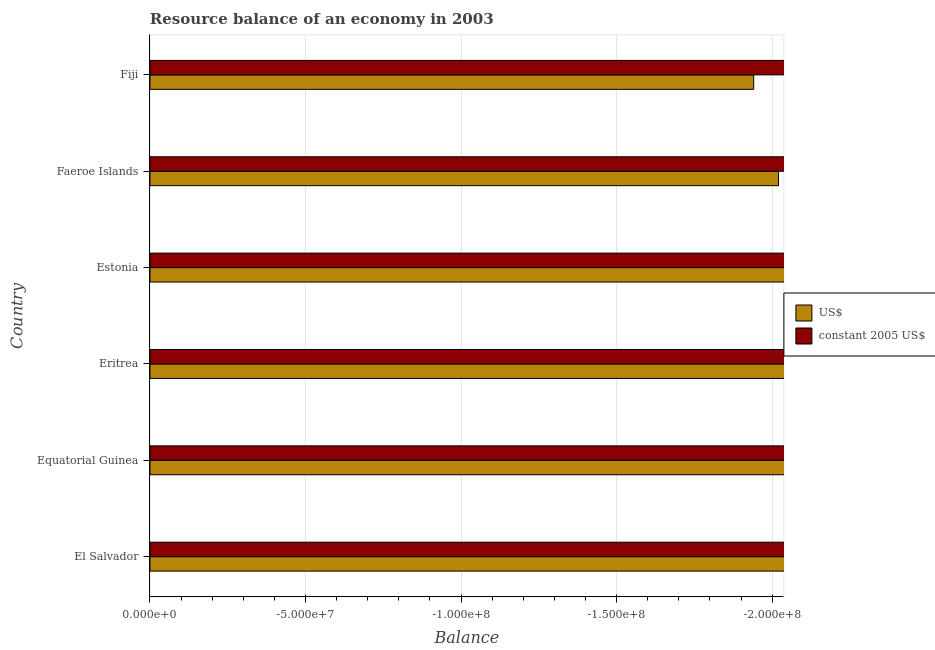Are the number of bars per tick equal to the number of legend labels?
Provide a short and direct response. No. Are the number of bars on each tick of the Y-axis equal?
Your answer should be very brief. Yes. How many bars are there on the 3rd tick from the top?
Keep it short and to the point. 0. What is the label of the 5th group of bars from the top?
Ensure brevity in your answer.  Equatorial Guinea. What is the resource balance in constant us$ in Estonia?
Keep it short and to the point. 0. What is the total resource balance in us$ in the graph?
Make the answer very short. 0. How many bars are there?
Keep it short and to the point. 0. Are all the bars in the graph horizontal?
Your answer should be very brief. Yes. What is the difference between two consecutive major ticks on the X-axis?
Keep it short and to the point. 5.00e+07. Are the values on the major ticks of X-axis written in scientific E-notation?
Offer a very short reply. Yes. Where does the legend appear in the graph?
Offer a terse response. Center right. How many legend labels are there?
Your response must be concise. 2. What is the title of the graph?
Offer a terse response. Resource balance of an economy in 2003. What is the label or title of the X-axis?
Offer a terse response. Balance. What is the Balance of US$ in El Salvador?
Make the answer very short. 0. What is the Balance in constant 2005 US$ in El Salvador?
Your response must be concise. 0. What is the Balance in US$ in Equatorial Guinea?
Provide a short and direct response. 0. What is the Balance in constant 2005 US$ in Equatorial Guinea?
Make the answer very short. 0. What is the Balance in constant 2005 US$ in Eritrea?
Provide a succinct answer. 0. What is the Balance in US$ in Estonia?
Provide a succinct answer. 0. What is the Balance in constant 2005 US$ in Faeroe Islands?
Provide a succinct answer. 0. What is the total Balance in US$ in the graph?
Your answer should be compact. 0. What is the total Balance in constant 2005 US$ in the graph?
Your answer should be very brief. 0. What is the average Balance in US$ per country?
Your answer should be very brief. 0. 